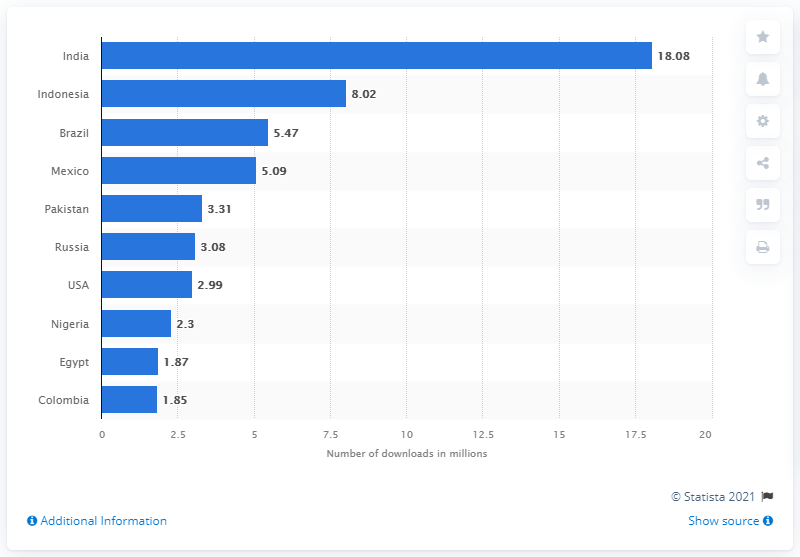Identify some key points in this picture. In the first quarter of 2021, Google Play users in India generated 18.08 million downloads of WhatsApp. 